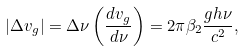Convert formula to latex. <formula><loc_0><loc_0><loc_500><loc_500>\left | \Delta v _ { g } \right | = \Delta \nu \left ( \frac { d v _ { g } } { d \nu } \right ) = 2 \pi \beta _ { 2 } \frac { g h \nu } { c ^ { 2 } } ,</formula> 